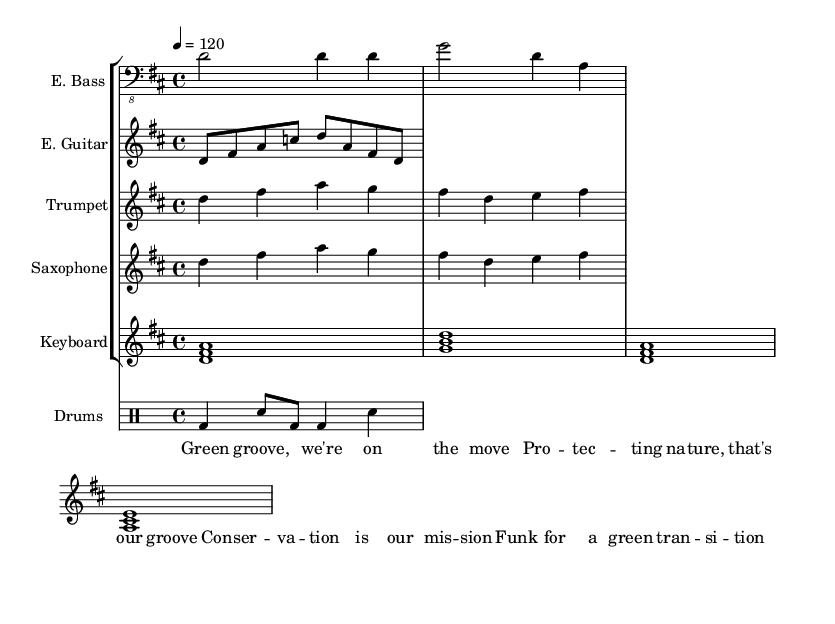What is the key signature of this music? The key signature is D major, which has two sharps (F# and C#). This can be identified by looking at the key signature notation at the beginning of the staff.
Answer: D major What is the time signature of this music? The time signature is 4/4, as indicated at the beginning of the score. This means there are four beats per measure, and the quarter note gets one beat.
Answer: 4/4 What is the tempo marking of this piece? The tempo marking indicates a speed of quarter note equals 120 beats per minute, as noted above the score. This tells us how fast the piece should be performed.
Answer: 120 How many instruments are playing in this piece? There are five instruments indicated in the score: Electric Bass, Electric Guitar, Trumpet, Saxophone, and Keyboard. Each instrument has its own staff in the score.
Answer: Five What is the main lyrical theme of the song? The lyrics celebrate environmental conservation and emphasize a collective movement ("Green groove, we're on the move"). This is highlighted in the lyrics section of the score.
Answer: Environmental conservation Which type of rhythm is predominantly used for the drums? The rhythmic pattern for the drums shows a combination of bass drum and snare hits, notably alternating between them, with both quarter and eighth notes indicating a funk rhythmic style.
Answer: Funk rhythm What aspect of music does the phrase "Funk for a green transition" refer to? This phrase in the lyrics signifies the connection between the energetic style of funk music and the advocacy for environmental awareness and change, underlining the message of the song.
Answer: Advocacy for environmental change 